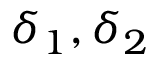<formula> <loc_0><loc_0><loc_500><loc_500>\delta _ { 1 } , \delta _ { 2 }</formula> 